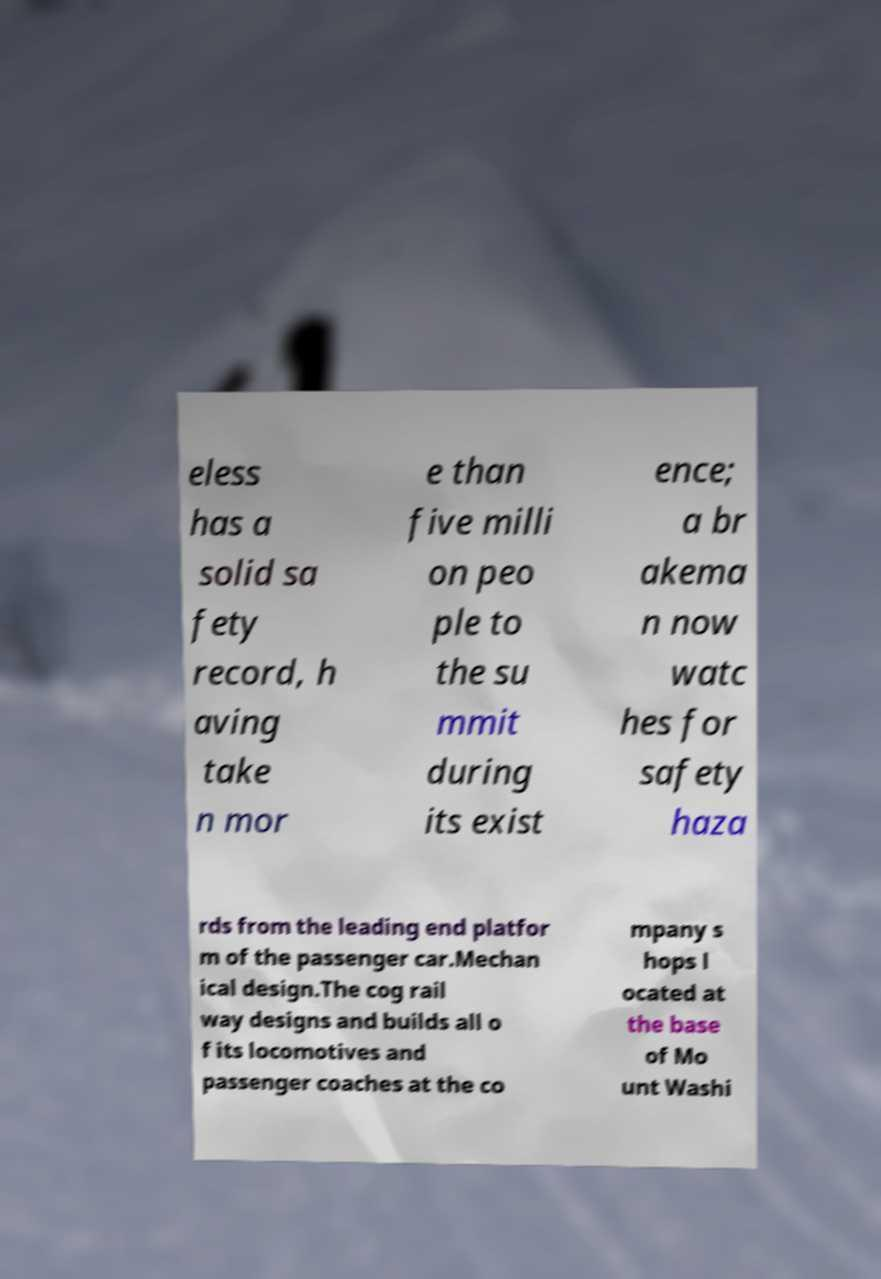What messages or text are displayed in this image? I need them in a readable, typed format. eless has a solid sa fety record, h aving take n mor e than five milli on peo ple to the su mmit during its exist ence; a br akema n now watc hes for safety haza rds from the leading end platfor m of the passenger car.Mechan ical design.The cog rail way designs and builds all o f its locomotives and passenger coaches at the co mpany s hops l ocated at the base of Mo unt Washi 